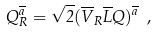Convert formula to latex. <formula><loc_0><loc_0><loc_500><loc_500>Q _ { R } ^ { \overline { a } } = \sqrt { 2 } ( \overline { V } _ { R } \overline { L } Q ) ^ { \overline { a } } \ ,</formula> 